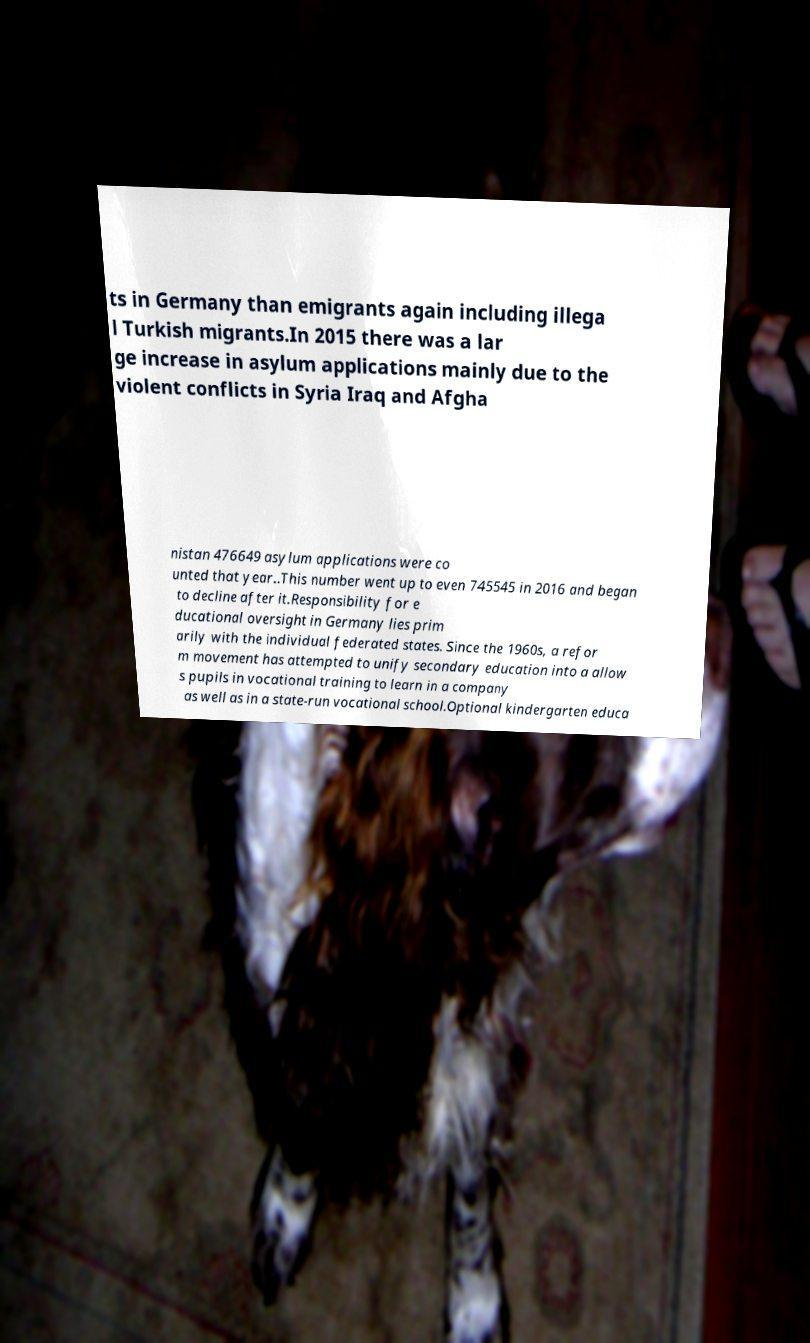Can you read and provide the text displayed in the image?This photo seems to have some interesting text. Can you extract and type it out for me? ts in Germany than emigrants again including illega l Turkish migrants.In 2015 there was a lar ge increase in asylum applications mainly due to the violent conflicts in Syria Iraq and Afgha nistan 476649 asylum applications were co unted that year..This number went up to even 745545 in 2016 and began to decline after it.Responsibility for e ducational oversight in Germany lies prim arily with the individual federated states. Since the 1960s, a refor m movement has attempted to unify secondary education into a allow s pupils in vocational training to learn in a company as well as in a state-run vocational school.Optional kindergarten educa 